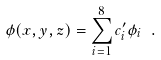<formula> <loc_0><loc_0><loc_500><loc_500>\phi ( x , y , z ) = \sum _ { i = 1 } ^ { 8 } c ^ { \prime } _ { i } \phi _ { i } \ .</formula> 